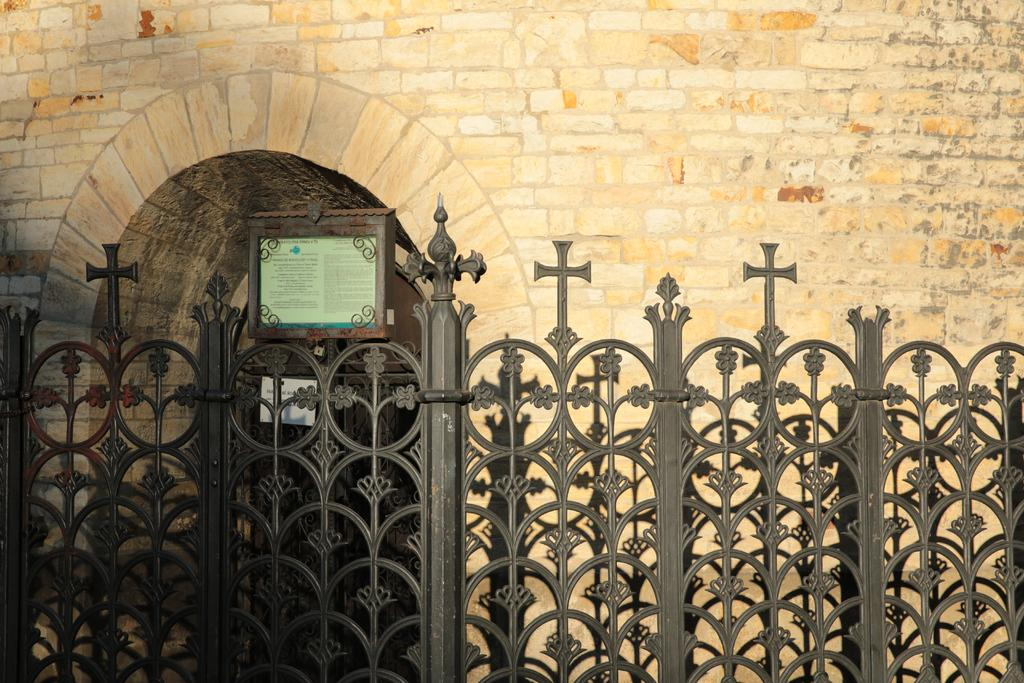What is the main structure in the center of the image? There is a gate in the center of the image. What can be seen in the background of the image? There is a wall, a door, and a board in the background of the image. What is written or displayed on the board? There is text on the board. How many clocks can be seen hanging on the gate in the image? There are no clocks visible on the gate in the image. What type of vessel is present in the image? There is no vessel present in the image. 